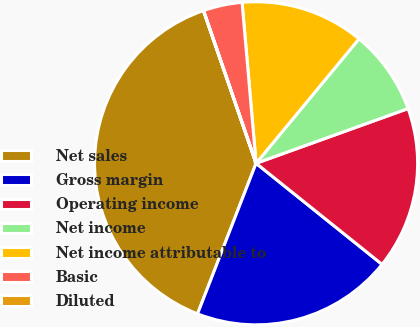Convert chart to OTSL. <chart><loc_0><loc_0><loc_500><loc_500><pie_chart><fcel>Net sales<fcel>Gross margin<fcel>Operating income<fcel>Net income<fcel>Net income attributable to<fcel>Basic<fcel>Diluted<nl><fcel>38.81%<fcel>20.14%<fcel>16.26%<fcel>8.5%<fcel>12.38%<fcel>3.89%<fcel>0.01%<nl></chart> 